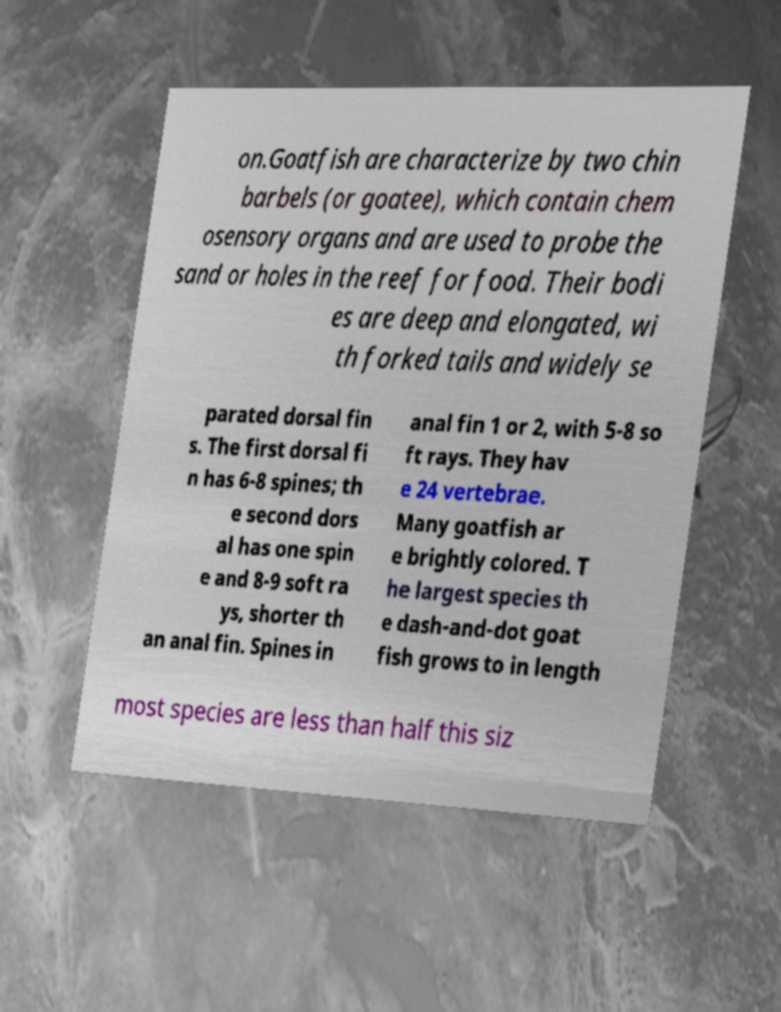Please identify and transcribe the text found in this image. on.Goatfish are characterize by two chin barbels (or goatee), which contain chem osensory organs and are used to probe the sand or holes in the reef for food. Their bodi es are deep and elongated, wi th forked tails and widely se parated dorsal fin s. The first dorsal fi n has 6-8 spines; th e second dors al has one spin e and 8-9 soft ra ys, shorter th an anal fin. Spines in anal fin 1 or 2, with 5-8 so ft rays. They hav e 24 vertebrae. Many goatfish ar e brightly colored. T he largest species th e dash-and-dot goat fish grows to in length most species are less than half this siz 